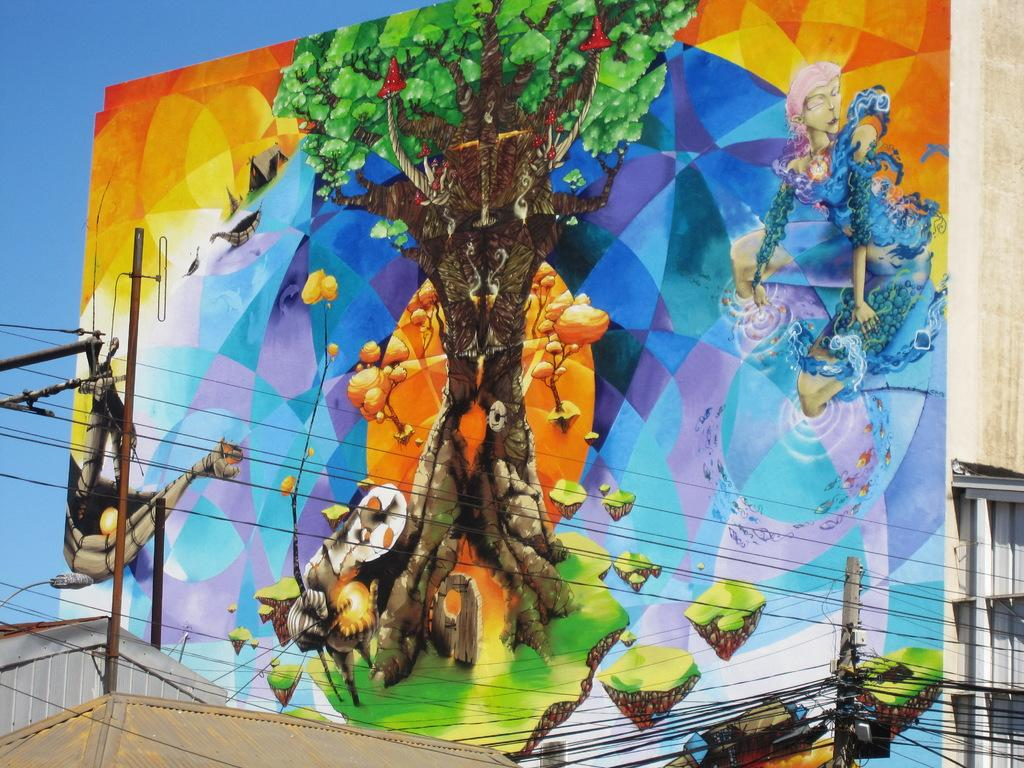What can be seen on the wall in the image? There are paintings on the wall in the image. What type of structures are present in the image? There are buildings in the image. What infrastructure elements are visible in the image? Electric poles, electric cables, a street light, and a street pole are visible in the image. What part of the natural environment is visible in the image? The sky is visible in the background of the image. What type of history can be seen in the image? There is no specific historical event or reference visible in the image. What type of spoon is used to eat the buildings in the image? There are no spoons present in the image, and buildings cannot be eaten. 